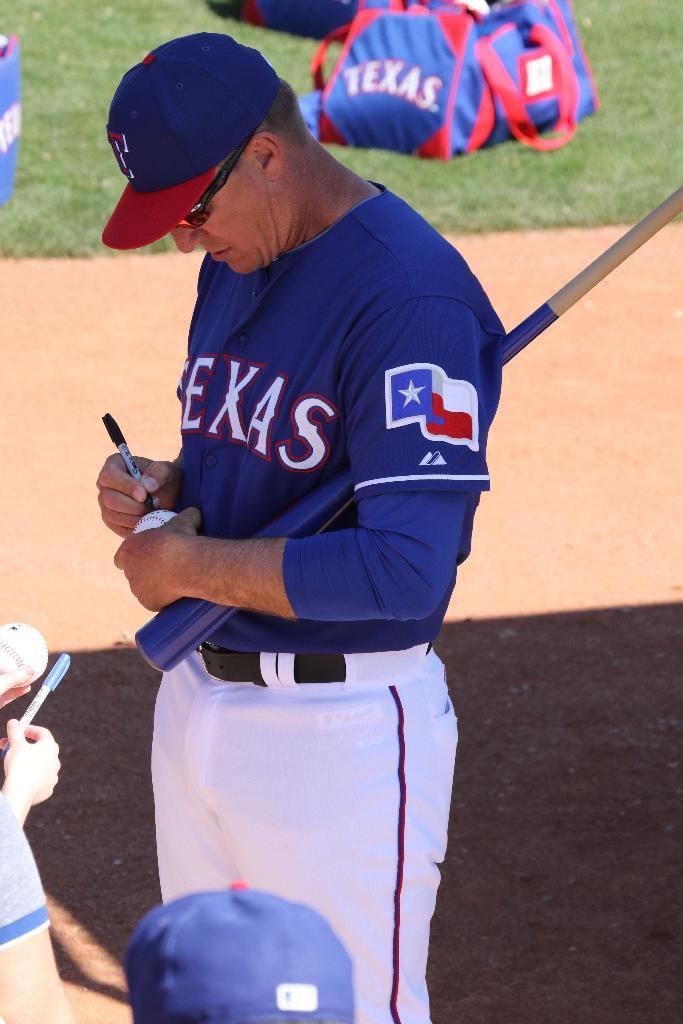<image>
Summarize the visual content of the image. A player on the Texas team signs a ball for a fan. 